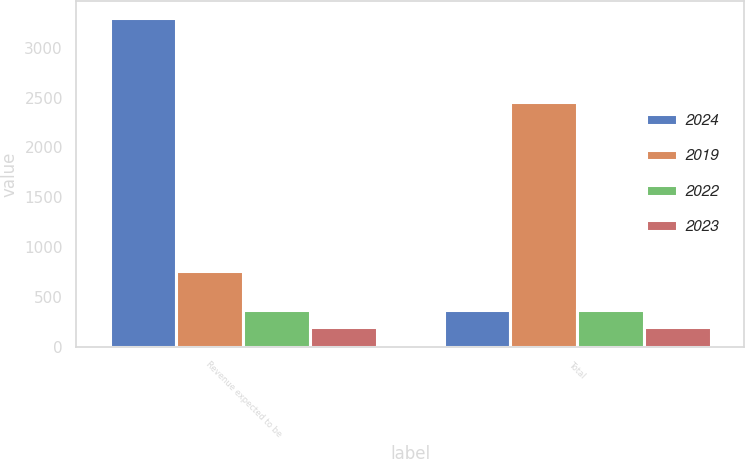Convert chart. <chart><loc_0><loc_0><loc_500><loc_500><stacked_bar_chart><ecel><fcel>Revenue expected to be<fcel>Total<nl><fcel>2024<fcel>3302<fcel>375<nl><fcel>2019<fcel>760<fcel>2460<nl><fcel>2022<fcel>375<fcel>375<nl><fcel>2023<fcel>203<fcel>203<nl></chart> 